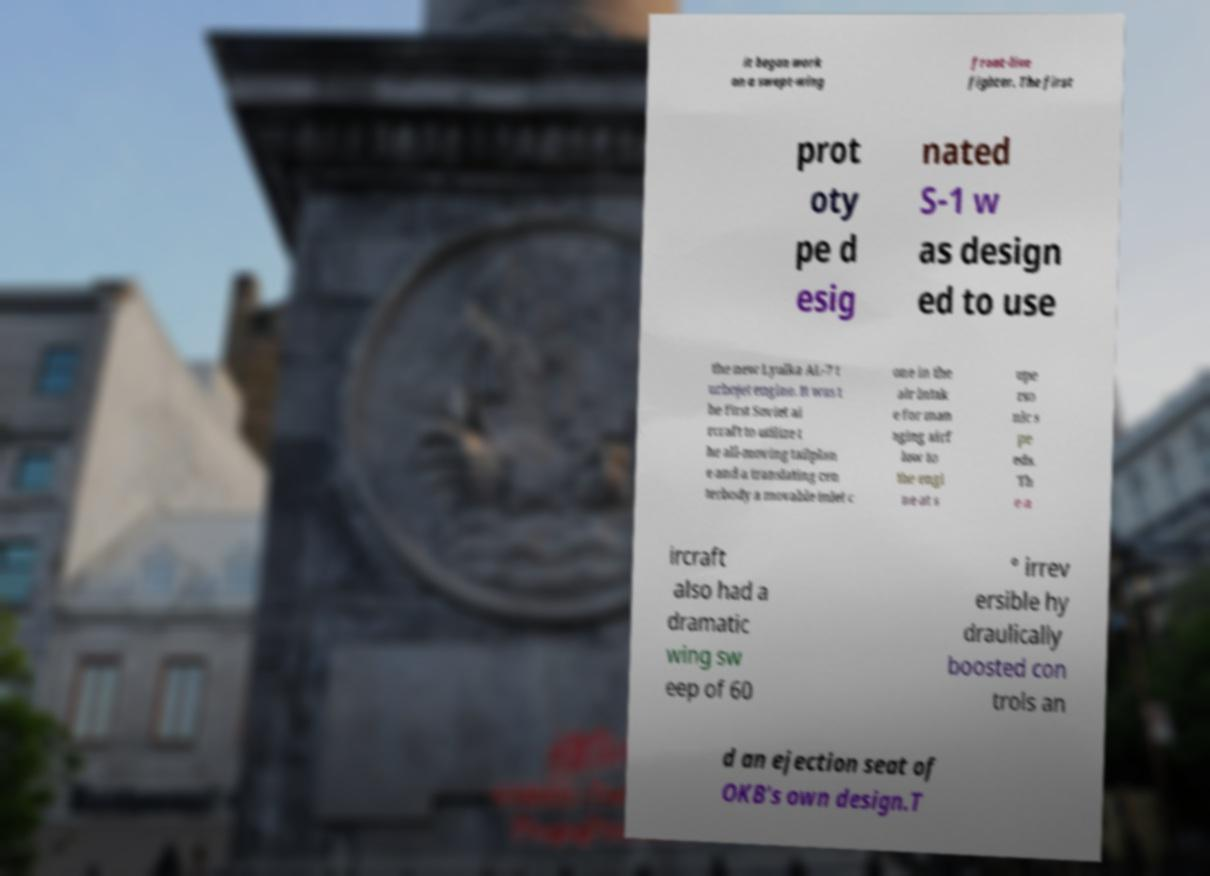Could you assist in decoding the text presented in this image and type it out clearly? it began work on a swept-wing front-line fighter. The first prot oty pe d esig nated S-1 w as design ed to use the new Lyulka AL-7 t urbojet engine. It was t he first Soviet ai rcraft to utilize t he all-moving tailplan e and a translating cen terbody a movable inlet c one in the air intak e for man aging airf low to the engi ne at s upe rso nic s pe eds. Th e a ircraft also had a dramatic wing sw eep of 60 ° irrev ersible hy draulically boosted con trols an d an ejection seat of OKB's own design.T 